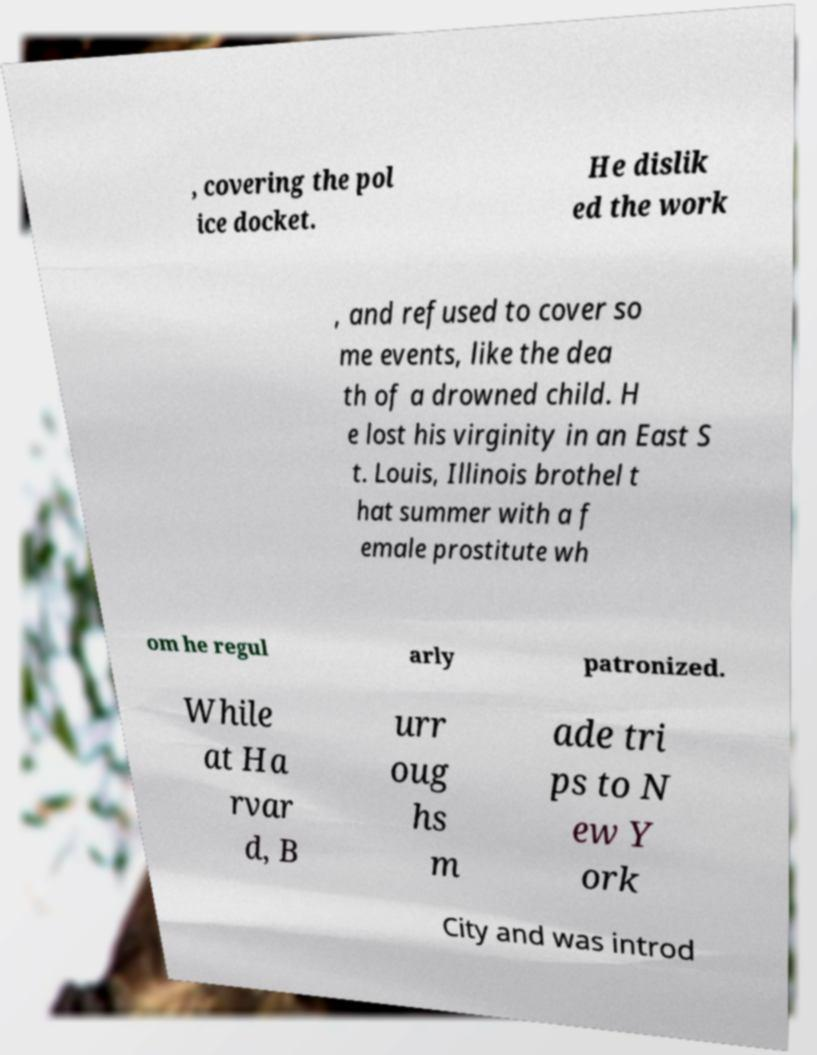Please identify and transcribe the text found in this image. , covering the pol ice docket. He dislik ed the work , and refused to cover so me events, like the dea th of a drowned child. H e lost his virginity in an East S t. Louis, Illinois brothel t hat summer with a f emale prostitute wh om he regul arly patronized. While at Ha rvar d, B urr oug hs m ade tri ps to N ew Y ork City and was introd 